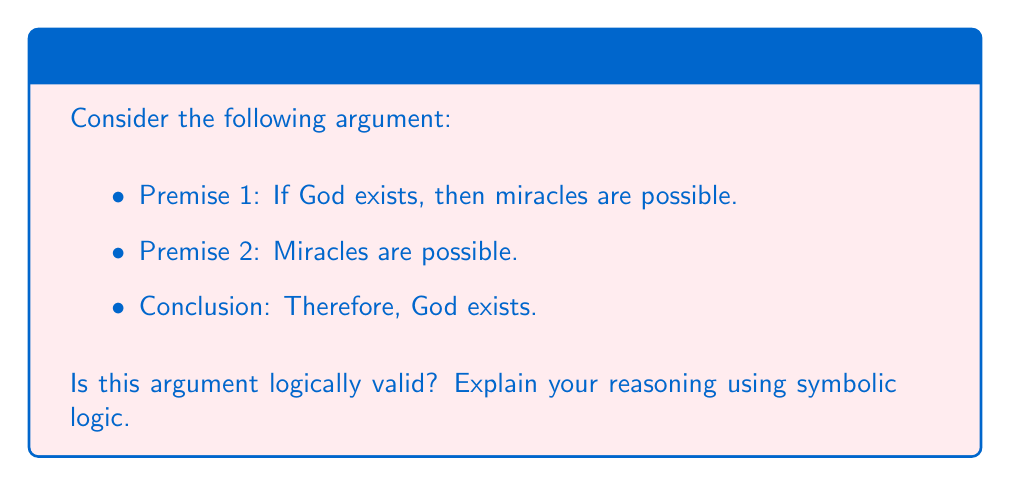Teach me how to tackle this problem. To analyze the logical validity of this argument, let's use symbolic logic:

Let:
$p$ = God exists
$q$ = Miracles are possible

The argument can be symbolized as:

1. $p \rightarrow q$ (If God exists, then miracles are possible)
2. $q$ (Miracles are possible)
3. $\therefore p$ (Therefore, God exists)

This argument form is known as the fallacy of affirming the consequent. To see why it's invalid, let's examine its structure:

$$(p \rightarrow q) \land q \therefore p$$

To prove invalidity, we need to show a case where the premises are true but the conclusion is false:

1. $p \rightarrow q$ is true when $p$ is false and $q$ is true
2. $q$ is true
3. But $p$ can still be false

This can be demonstrated with a truth table:

$$\begin{array}{|c|c|c|c|}
\hline
p & q & p \rightarrow q & ((p \rightarrow q) \land q) \rightarrow p \\
\hline
T & T & T & T \\
T & F & F & T \\
F & T & T & F \\
F & F & T & T \\
\hline
\end{array}$$

The third row shows a case where the premises are true but the conclusion is false, proving the argument is invalid.

In the context of the given persona, while a devout Catholic might find the premises and conclusion agreeable, the logical structure of the argument itself is not valid. This demonstrates that logical validity is independent of the truth or personal belief in the premises or conclusion.
Answer: Invalid 